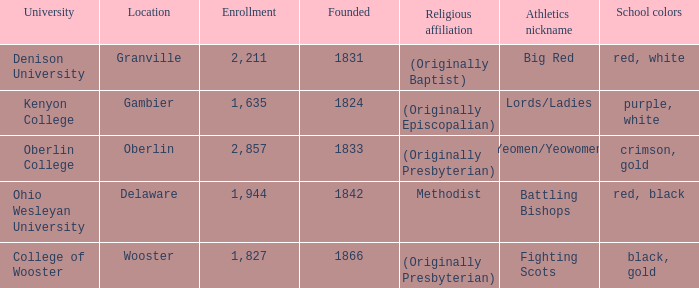What was the religious affiliation for the athletics nicknamed lords/ladies? (Originally Episcopalian). 